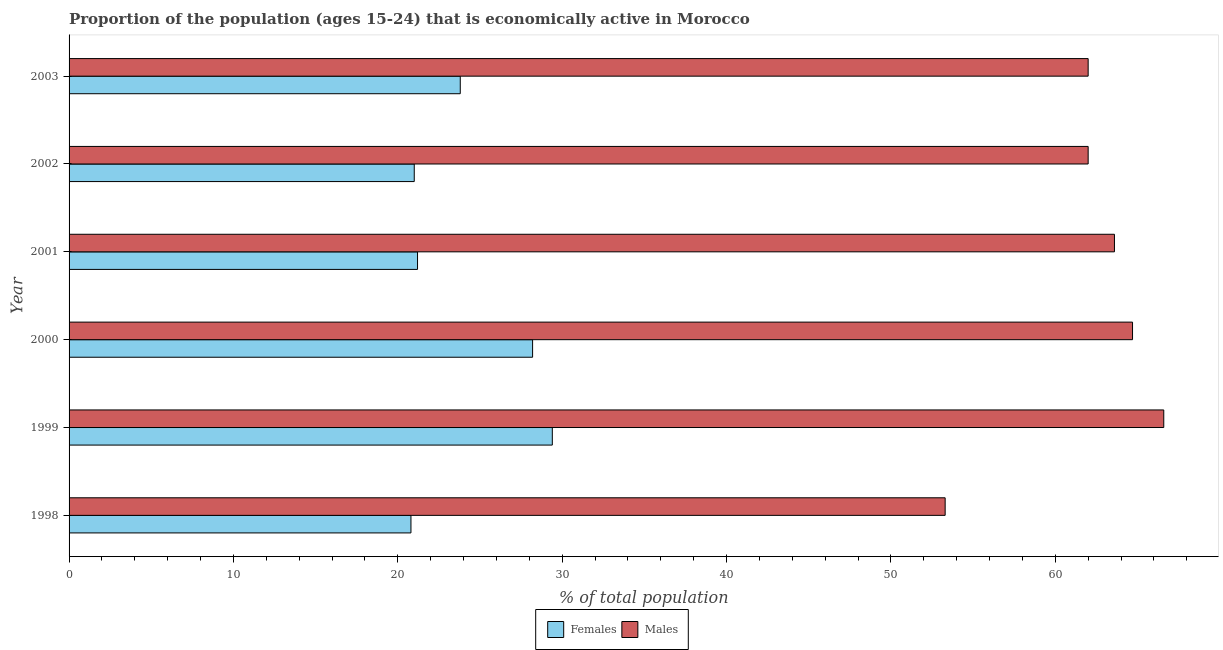How many bars are there on the 2nd tick from the bottom?
Keep it short and to the point. 2. What is the label of the 3rd group of bars from the top?
Provide a short and direct response. 2001. What is the percentage of economically active female population in 2001?
Ensure brevity in your answer.  21.2. Across all years, what is the maximum percentage of economically active male population?
Keep it short and to the point. 66.6. Across all years, what is the minimum percentage of economically active female population?
Offer a very short reply. 20.8. In which year was the percentage of economically active male population minimum?
Provide a short and direct response. 1998. What is the total percentage of economically active female population in the graph?
Provide a succinct answer. 144.4. What is the difference between the percentage of economically active male population in 2001 and that in 2002?
Your response must be concise. 1.6. What is the difference between the percentage of economically active male population in 2002 and the percentage of economically active female population in 1999?
Keep it short and to the point. 32.6. What is the average percentage of economically active male population per year?
Ensure brevity in your answer.  62.03. In the year 1999, what is the difference between the percentage of economically active male population and percentage of economically active female population?
Make the answer very short. 37.2. What is the ratio of the percentage of economically active male population in 1998 to that in 2000?
Offer a very short reply. 0.82. Is the difference between the percentage of economically active female population in 1999 and 2000 greater than the difference between the percentage of economically active male population in 1999 and 2000?
Offer a very short reply. No. What is the difference between the highest and the second highest percentage of economically active male population?
Ensure brevity in your answer.  1.9. What is the difference between the highest and the lowest percentage of economically active male population?
Provide a succinct answer. 13.3. In how many years, is the percentage of economically active female population greater than the average percentage of economically active female population taken over all years?
Your response must be concise. 2. Is the sum of the percentage of economically active female population in 1999 and 2000 greater than the maximum percentage of economically active male population across all years?
Your answer should be compact. No. What does the 1st bar from the top in 2001 represents?
Your answer should be compact. Males. What does the 1st bar from the bottom in 2003 represents?
Your response must be concise. Females. How many years are there in the graph?
Provide a short and direct response. 6. What is the difference between two consecutive major ticks on the X-axis?
Your response must be concise. 10. Are the values on the major ticks of X-axis written in scientific E-notation?
Your response must be concise. No. Does the graph contain any zero values?
Your response must be concise. No. How many legend labels are there?
Your answer should be compact. 2. What is the title of the graph?
Offer a very short reply. Proportion of the population (ages 15-24) that is economically active in Morocco. Does "Services" appear as one of the legend labels in the graph?
Provide a short and direct response. No. What is the label or title of the X-axis?
Provide a succinct answer. % of total population. What is the % of total population of Females in 1998?
Offer a very short reply. 20.8. What is the % of total population in Males in 1998?
Offer a terse response. 53.3. What is the % of total population in Females in 1999?
Keep it short and to the point. 29.4. What is the % of total population in Males in 1999?
Your answer should be very brief. 66.6. What is the % of total population in Females in 2000?
Offer a terse response. 28.2. What is the % of total population of Males in 2000?
Give a very brief answer. 64.7. What is the % of total population of Females in 2001?
Provide a short and direct response. 21.2. What is the % of total population in Males in 2001?
Ensure brevity in your answer.  63.6. What is the % of total population of Females in 2003?
Your answer should be very brief. 23.8. Across all years, what is the maximum % of total population in Females?
Provide a succinct answer. 29.4. Across all years, what is the maximum % of total population of Males?
Your answer should be compact. 66.6. Across all years, what is the minimum % of total population in Females?
Provide a short and direct response. 20.8. Across all years, what is the minimum % of total population in Males?
Give a very brief answer. 53.3. What is the total % of total population of Females in the graph?
Offer a very short reply. 144.4. What is the total % of total population of Males in the graph?
Give a very brief answer. 372.2. What is the difference between the % of total population of Males in 1998 and that in 1999?
Provide a short and direct response. -13.3. What is the difference between the % of total population in Females in 1998 and that in 2000?
Ensure brevity in your answer.  -7.4. What is the difference between the % of total population of Males in 1998 and that in 2000?
Provide a short and direct response. -11.4. What is the difference between the % of total population in Females in 1998 and that in 2001?
Offer a very short reply. -0.4. What is the difference between the % of total population of Males in 1998 and that in 2002?
Make the answer very short. -8.7. What is the difference between the % of total population of Males in 1998 and that in 2003?
Provide a succinct answer. -8.7. What is the difference between the % of total population in Males in 1999 and that in 2000?
Keep it short and to the point. 1.9. What is the difference between the % of total population in Males in 1999 and that in 2001?
Provide a succinct answer. 3. What is the difference between the % of total population in Females in 2000 and that in 2001?
Provide a succinct answer. 7. What is the difference between the % of total population in Males in 2000 and that in 2001?
Your answer should be compact. 1.1. What is the difference between the % of total population of Females in 2000 and that in 2002?
Provide a short and direct response. 7.2. What is the difference between the % of total population in Males in 2000 and that in 2002?
Provide a short and direct response. 2.7. What is the difference between the % of total population in Females in 2000 and that in 2003?
Make the answer very short. 4.4. What is the difference between the % of total population in Males in 2000 and that in 2003?
Provide a succinct answer. 2.7. What is the difference between the % of total population of Females in 2001 and that in 2002?
Your answer should be very brief. 0.2. What is the difference between the % of total population in Males in 2001 and that in 2002?
Offer a very short reply. 1.6. What is the difference between the % of total population in Females in 1998 and the % of total population in Males in 1999?
Offer a very short reply. -45.8. What is the difference between the % of total population of Females in 1998 and the % of total population of Males in 2000?
Provide a short and direct response. -43.9. What is the difference between the % of total population of Females in 1998 and the % of total population of Males in 2001?
Your answer should be very brief. -42.8. What is the difference between the % of total population in Females in 1998 and the % of total population in Males in 2002?
Give a very brief answer. -41.2. What is the difference between the % of total population of Females in 1998 and the % of total population of Males in 2003?
Ensure brevity in your answer.  -41.2. What is the difference between the % of total population of Females in 1999 and the % of total population of Males in 2000?
Your response must be concise. -35.3. What is the difference between the % of total population in Females in 1999 and the % of total population in Males in 2001?
Your response must be concise. -34.2. What is the difference between the % of total population in Females in 1999 and the % of total population in Males in 2002?
Provide a short and direct response. -32.6. What is the difference between the % of total population in Females in 1999 and the % of total population in Males in 2003?
Your answer should be compact. -32.6. What is the difference between the % of total population in Females in 2000 and the % of total population in Males in 2001?
Your response must be concise. -35.4. What is the difference between the % of total population in Females in 2000 and the % of total population in Males in 2002?
Provide a short and direct response. -33.8. What is the difference between the % of total population of Females in 2000 and the % of total population of Males in 2003?
Your answer should be compact. -33.8. What is the difference between the % of total population in Females in 2001 and the % of total population in Males in 2002?
Provide a short and direct response. -40.8. What is the difference between the % of total population of Females in 2001 and the % of total population of Males in 2003?
Provide a succinct answer. -40.8. What is the difference between the % of total population of Females in 2002 and the % of total population of Males in 2003?
Your answer should be very brief. -41. What is the average % of total population of Females per year?
Your answer should be compact. 24.07. What is the average % of total population in Males per year?
Your answer should be very brief. 62.03. In the year 1998, what is the difference between the % of total population in Females and % of total population in Males?
Give a very brief answer. -32.5. In the year 1999, what is the difference between the % of total population in Females and % of total population in Males?
Your answer should be compact. -37.2. In the year 2000, what is the difference between the % of total population in Females and % of total population in Males?
Your answer should be compact. -36.5. In the year 2001, what is the difference between the % of total population in Females and % of total population in Males?
Keep it short and to the point. -42.4. In the year 2002, what is the difference between the % of total population of Females and % of total population of Males?
Ensure brevity in your answer.  -41. In the year 2003, what is the difference between the % of total population in Females and % of total population in Males?
Provide a short and direct response. -38.2. What is the ratio of the % of total population in Females in 1998 to that in 1999?
Make the answer very short. 0.71. What is the ratio of the % of total population in Males in 1998 to that in 1999?
Give a very brief answer. 0.8. What is the ratio of the % of total population of Females in 1998 to that in 2000?
Provide a short and direct response. 0.74. What is the ratio of the % of total population of Males in 1998 to that in 2000?
Offer a very short reply. 0.82. What is the ratio of the % of total population of Females in 1998 to that in 2001?
Provide a short and direct response. 0.98. What is the ratio of the % of total population of Males in 1998 to that in 2001?
Offer a terse response. 0.84. What is the ratio of the % of total population of Males in 1998 to that in 2002?
Offer a terse response. 0.86. What is the ratio of the % of total population in Females in 1998 to that in 2003?
Make the answer very short. 0.87. What is the ratio of the % of total population in Males in 1998 to that in 2003?
Offer a terse response. 0.86. What is the ratio of the % of total population in Females in 1999 to that in 2000?
Offer a very short reply. 1.04. What is the ratio of the % of total population in Males in 1999 to that in 2000?
Offer a terse response. 1.03. What is the ratio of the % of total population of Females in 1999 to that in 2001?
Provide a succinct answer. 1.39. What is the ratio of the % of total population in Males in 1999 to that in 2001?
Your response must be concise. 1.05. What is the ratio of the % of total population in Males in 1999 to that in 2002?
Give a very brief answer. 1.07. What is the ratio of the % of total population in Females in 1999 to that in 2003?
Make the answer very short. 1.24. What is the ratio of the % of total population of Males in 1999 to that in 2003?
Your answer should be very brief. 1.07. What is the ratio of the % of total population in Females in 2000 to that in 2001?
Your response must be concise. 1.33. What is the ratio of the % of total population in Males in 2000 to that in 2001?
Ensure brevity in your answer.  1.02. What is the ratio of the % of total population of Females in 2000 to that in 2002?
Your answer should be very brief. 1.34. What is the ratio of the % of total population of Males in 2000 to that in 2002?
Offer a terse response. 1.04. What is the ratio of the % of total population of Females in 2000 to that in 2003?
Ensure brevity in your answer.  1.18. What is the ratio of the % of total population in Males in 2000 to that in 2003?
Offer a terse response. 1.04. What is the ratio of the % of total population of Females in 2001 to that in 2002?
Offer a terse response. 1.01. What is the ratio of the % of total population in Males in 2001 to that in 2002?
Offer a terse response. 1.03. What is the ratio of the % of total population of Females in 2001 to that in 2003?
Make the answer very short. 0.89. What is the ratio of the % of total population in Males in 2001 to that in 2003?
Your answer should be compact. 1.03. What is the ratio of the % of total population in Females in 2002 to that in 2003?
Your response must be concise. 0.88. What is the difference between the highest and the second highest % of total population in Females?
Provide a short and direct response. 1.2. 